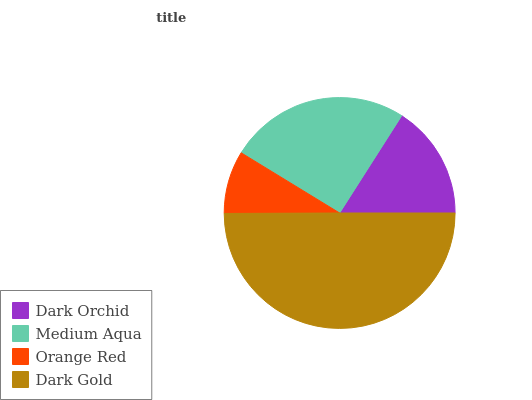Is Orange Red the minimum?
Answer yes or no. Yes. Is Dark Gold the maximum?
Answer yes or no. Yes. Is Medium Aqua the minimum?
Answer yes or no. No. Is Medium Aqua the maximum?
Answer yes or no. No. Is Medium Aqua greater than Dark Orchid?
Answer yes or no. Yes. Is Dark Orchid less than Medium Aqua?
Answer yes or no. Yes. Is Dark Orchid greater than Medium Aqua?
Answer yes or no. No. Is Medium Aqua less than Dark Orchid?
Answer yes or no. No. Is Medium Aqua the high median?
Answer yes or no. Yes. Is Dark Orchid the low median?
Answer yes or no. Yes. Is Orange Red the high median?
Answer yes or no. No. Is Medium Aqua the low median?
Answer yes or no. No. 